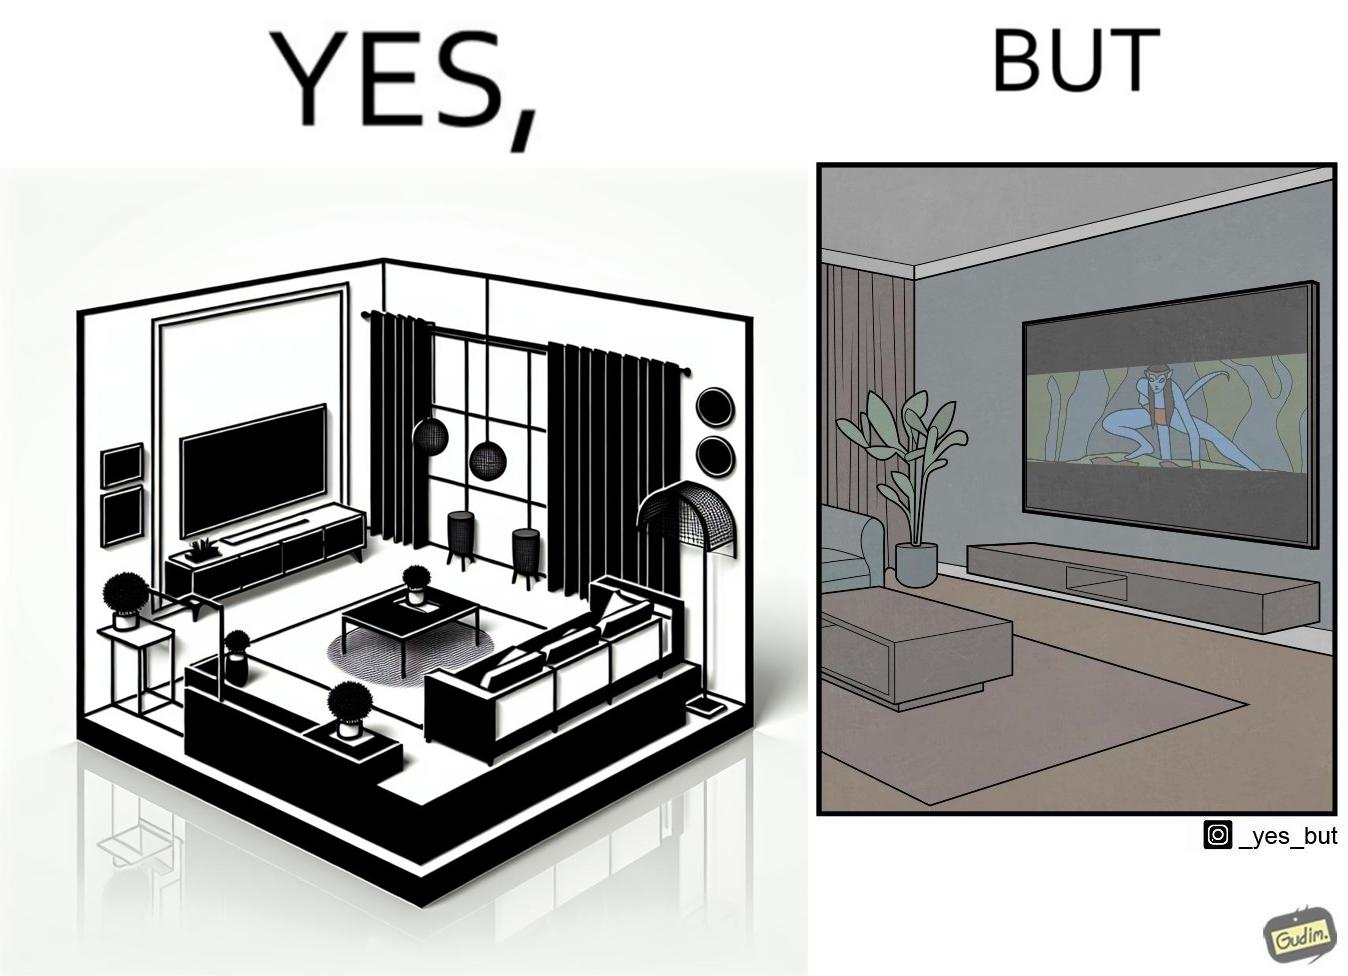What is shown in the left half versus the right half of this image? In the left part of the image: The image shows the living area in a home. The room has a big TV hanging on the wall. In the right part of the image: The image shows the living area in a home. The room has a big TV hanging on the wall playing a movie. The movie is not using the entire screen and top and bottom areas of the screen is unused. 